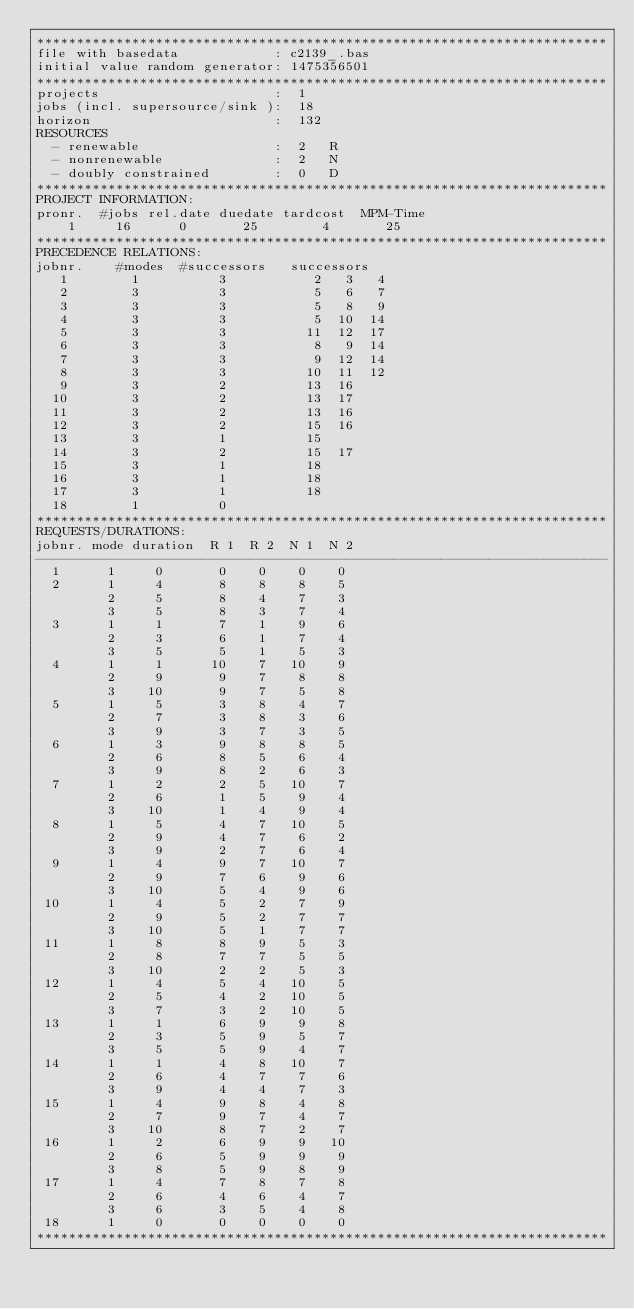Convert code to text. <code><loc_0><loc_0><loc_500><loc_500><_ObjectiveC_>************************************************************************
file with basedata            : c2139_.bas
initial value random generator: 1475356501
************************************************************************
projects                      :  1
jobs (incl. supersource/sink ):  18
horizon                       :  132
RESOURCES
  - renewable                 :  2   R
  - nonrenewable              :  2   N
  - doubly constrained        :  0   D
************************************************************************
PROJECT INFORMATION:
pronr.  #jobs rel.date duedate tardcost  MPM-Time
    1     16      0       25        4       25
************************************************************************
PRECEDENCE RELATIONS:
jobnr.    #modes  #successors   successors
   1        1          3           2   3   4
   2        3          3           5   6   7
   3        3          3           5   8   9
   4        3          3           5  10  14
   5        3          3          11  12  17
   6        3          3           8   9  14
   7        3          3           9  12  14
   8        3          3          10  11  12
   9        3          2          13  16
  10        3          2          13  17
  11        3          2          13  16
  12        3          2          15  16
  13        3          1          15
  14        3          2          15  17
  15        3          1          18
  16        3          1          18
  17        3          1          18
  18        1          0        
************************************************************************
REQUESTS/DURATIONS:
jobnr. mode duration  R 1  R 2  N 1  N 2
------------------------------------------------------------------------
  1      1     0       0    0    0    0
  2      1     4       8    8    8    5
         2     5       8    4    7    3
         3     5       8    3    7    4
  3      1     1       7    1    9    6
         2     3       6    1    7    4
         3     5       5    1    5    3
  4      1     1      10    7   10    9
         2     9       9    7    8    8
         3    10       9    7    5    8
  5      1     5       3    8    4    7
         2     7       3    8    3    6
         3     9       3    7    3    5
  6      1     3       9    8    8    5
         2     6       8    5    6    4
         3     9       8    2    6    3
  7      1     2       2    5   10    7
         2     6       1    5    9    4
         3    10       1    4    9    4
  8      1     5       4    7   10    5
         2     9       4    7    6    2
         3     9       2    7    6    4
  9      1     4       9    7   10    7
         2     9       7    6    9    6
         3    10       5    4    9    6
 10      1     4       5    2    7    9
         2     9       5    2    7    7
         3    10       5    1    7    7
 11      1     8       8    9    5    3
         2     8       7    7    5    5
         3    10       2    2    5    3
 12      1     4       5    4   10    5
         2     5       4    2   10    5
         3     7       3    2   10    5
 13      1     1       6    9    9    8
         2     3       5    9    5    7
         3     5       5    9    4    7
 14      1     1       4    8   10    7
         2     6       4    7    7    6
         3     9       4    4    7    3
 15      1     4       9    8    4    8
         2     7       9    7    4    7
         3    10       8    7    2    7
 16      1     2       6    9    9   10
         2     6       5    9    9    9
         3     8       5    9    8    9
 17      1     4       7    8    7    8
         2     6       4    6    4    7
         3     6       3    5    4    8
 18      1     0       0    0    0    0
************************************************************************</code> 